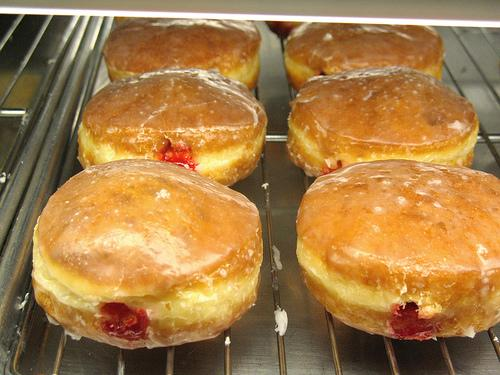What is the emotional sentiment associated with the image? Enjoyment and satisfaction from delicious freshly made donuts. List the colors of the elements found within the image. Red, white, and gray. Describe any remnants left on the cooling rack. There is a glob of white frosting left on the wire rack. Provide a short description of the main focus in the image. Numerous glazed jelly-filled donuts on a wire cooling rack, with some frosting left behind on the rack and holes visible from the jelly filling process. What type of rack are the donuts placed on? A gray metal wire cooling rack. What is the apparent purpose of these donuts? Freshly made glazed jelly donuts for sale at a donut shop. Describe the interaction between the donuts and the cooling rack. The donuts are placed on the cooling rack allowing air circulation underneath, and some frosting from the donuts has been left on the rack. Explain the filling process visible in the donuts. Donuts have holes poked into them for the jelly to be inserted. What type of jelly can be seen in the donuts? Red strawberry jam. How many jelly filled donuts are shown in the image? Six jelly filled donuts. 